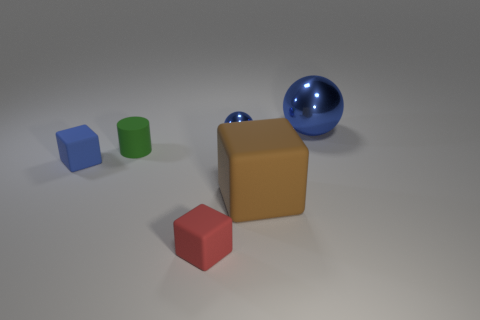Subtract all cyan cylinders. Subtract all purple cubes. How many cylinders are left? 1 Add 1 tiny green things. How many objects exist? 7 Subtract all cylinders. How many objects are left? 5 Add 5 large shiny balls. How many large shiny balls exist? 6 Subtract 0 purple blocks. How many objects are left? 6 Subtract all tiny cyan spheres. Subtract all big blue spheres. How many objects are left? 5 Add 4 brown matte things. How many brown matte things are left? 5 